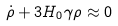<formula> <loc_0><loc_0><loc_500><loc_500>\dot { \rho } + 3 H _ { 0 } \gamma \rho \approx 0</formula> 